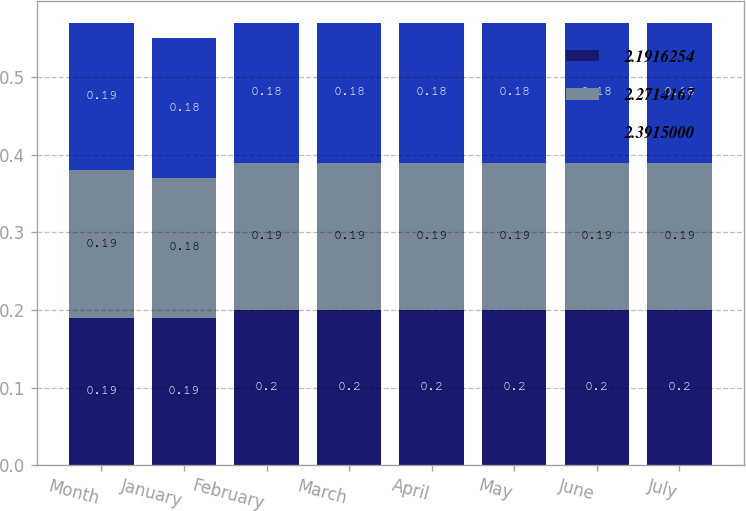Convert chart. <chart><loc_0><loc_0><loc_500><loc_500><stacked_bar_chart><ecel><fcel>Month<fcel>January<fcel>February<fcel>March<fcel>April<fcel>May<fcel>June<fcel>July<nl><fcel>2.19163<fcel>0.19<fcel>0.19<fcel>0.2<fcel>0.2<fcel>0.2<fcel>0.2<fcel>0.2<fcel>0.2<nl><fcel>2.27142<fcel>0.19<fcel>0.18<fcel>0.19<fcel>0.19<fcel>0.19<fcel>0.19<fcel>0.19<fcel>0.19<nl><fcel>2.3915<fcel>0.19<fcel>0.18<fcel>0.18<fcel>0.18<fcel>0.18<fcel>0.18<fcel>0.18<fcel>0.18<nl></chart> 